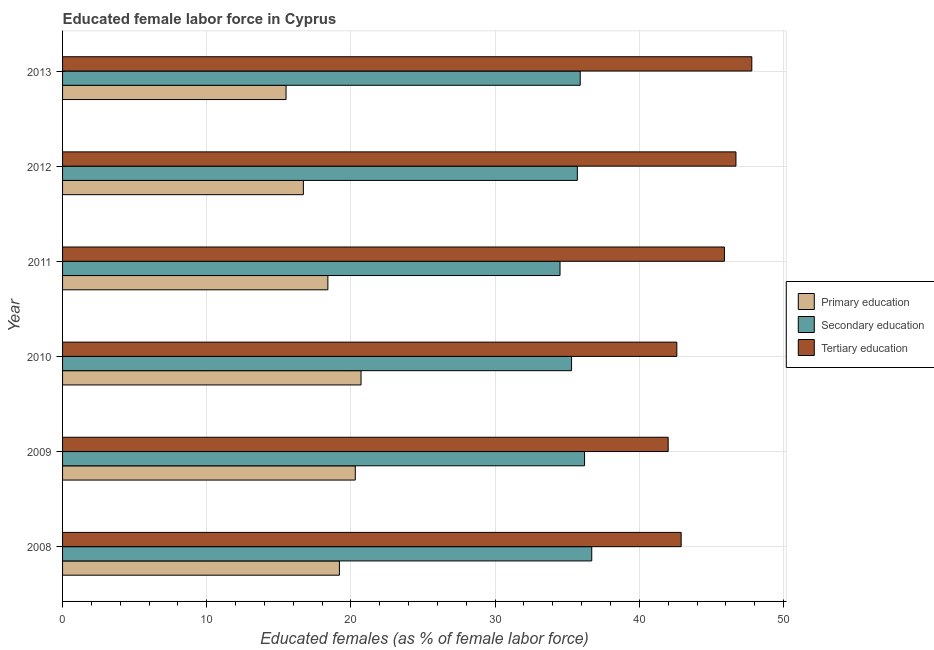How many different coloured bars are there?
Your response must be concise. 3. Are the number of bars on each tick of the Y-axis equal?
Your response must be concise. Yes. What is the percentage of female labor force who received tertiary education in 2008?
Provide a succinct answer. 42.9. Across all years, what is the maximum percentage of female labor force who received primary education?
Offer a very short reply. 20.7. Across all years, what is the minimum percentage of female labor force who received primary education?
Provide a short and direct response. 15.5. In which year was the percentage of female labor force who received primary education maximum?
Make the answer very short. 2010. In which year was the percentage of female labor force who received primary education minimum?
Offer a terse response. 2013. What is the total percentage of female labor force who received tertiary education in the graph?
Ensure brevity in your answer.  267.9. What is the difference between the percentage of female labor force who received tertiary education in 2009 and that in 2011?
Give a very brief answer. -3.9. What is the average percentage of female labor force who received secondary education per year?
Offer a very short reply. 35.72. What is the ratio of the percentage of female labor force who received tertiary education in 2008 to that in 2013?
Keep it short and to the point. 0.9. Is the percentage of female labor force who received primary education in 2010 less than that in 2012?
Ensure brevity in your answer.  No. Is the difference between the percentage of female labor force who received tertiary education in 2010 and 2011 greater than the difference between the percentage of female labor force who received primary education in 2010 and 2011?
Offer a terse response. No. What does the 1st bar from the top in 2008 represents?
Offer a very short reply. Tertiary education. What does the 2nd bar from the bottom in 2011 represents?
Make the answer very short. Secondary education. Is it the case that in every year, the sum of the percentage of female labor force who received primary education and percentage of female labor force who received secondary education is greater than the percentage of female labor force who received tertiary education?
Ensure brevity in your answer.  Yes. Are all the bars in the graph horizontal?
Your response must be concise. Yes. Are the values on the major ticks of X-axis written in scientific E-notation?
Provide a short and direct response. No. Does the graph contain any zero values?
Make the answer very short. No. Where does the legend appear in the graph?
Make the answer very short. Center right. How many legend labels are there?
Ensure brevity in your answer.  3. What is the title of the graph?
Give a very brief answer. Educated female labor force in Cyprus. Does "Manufactures" appear as one of the legend labels in the graph?
Give a very brief answer. No. What is the label or title of the X-axis?
Your answer should be very brief. Educated females (as % of female labor force). What is the Educated females (as % of female labor force) of Primary education in 2008?
Ensure brevity in your answer.  19.2. What is the Educated females (as % of female labor force) of Secondary education in 2008?
Make the answer very short. 36.7. What is the Educated females (as % of female labor force) of Tertiary education in 2008?
Offer a terse response. 42.9. What is the Educated females (as % of female labor force) in Primary education in 2009?
Provide a short and direct response. 20.3. What is the Educated females (as % of female labor force) of Secondary education in 2009?
Your answer should be compact. 36.2. What is the Educated females (as % of female labor force) of Tertiary education in 2009?
Your answer should be very brief. 42. What is the Educated females (as % of female labor force) of Primary education in 2010?
Give a very brief answer. 20.7. What is the Educated females (as % of female labor force) of Secondary education in 2010?
Your response must be concise. 35.3. What is the Educated females (as % of female labor force) in Tertiary education in 2010?
Give a very brief answer. 42.6. What is the Educated females (as % of female labor force) of Primary education in 2011?
Your response must be concise. 18.4. What is the Educated females (as % of female labor force) in Secondary education in 2011?
Ensure brevity in your answer.  34.5. What is the Educated females (as % of female labor force) of Tertiary education in 2011?
Your answer should be compact. 45.9. What is the Educated females (as % of female labor force) in Primary education in 2012?
Provide a succinct answer. 16.7. What is the Educated females (as % of female labor force) in Secondary education in 2012?
Provide a short and direct response. 35.7. What is the Educated females (as % of female labor force) of Tertiary education in 2012?
Ensure brevity in your answer.  46.7. What is the Educated females (as % of female labor force) of Secondary education in 2013?
Your answer should be very brief. 35.9. What is the Educated females (as % of female labor force) in Tertiary education in 2013?
Provide a succinct answer. 47.8. Across all years, what is the maximum Educated females (as % of female labor force) in Primary education?
Ensure brevity in your answer.  20.7. Across all years, what is the maximum Educated females (as % of female labor force) of Secondary education?
Provide a short and direct response. 36.7. Across all years, what is the maximum Educated females (as % of female labor force) in Tertiary education?
Give a very brief answer. 47.8. Across all years, what is the minimum Educated females (as % of female labor force) in Primary education?
Keep it short and to the point. 15.5. Across all years, what is the minimum Educated females (as % of female labor force) of Secondary education?
Keep it short and to the point. 34.5. What is the total Educated females (as % of female labor force) of Primary education in the graph?
Your response must be concise. 110.8. What is the total Educated females (as % of female labor force) of Secondary education in the graph?
Your response must be concise. 214.3. What is the total Educated females (as % of female labor force) in Tertiary education in the graph?
Keep it short and to the point. 267.9. What is the difference between the Educated females (as % of female labor force) of Primary education in 2008 and that in 2009?
Provide a succinct answer. -1.1. What is the difference between the Educated females (as % of female labor force) in Tertiary education in 2008 and that in 2009?
Give a very brief answer. 0.9. What is the difference between the Educated females (as % of female labor force) in Primary education in 2008 and that in 2010?
Provide a short and direct response. -1.5. What is the difference between the Educated females (as % of female labor force) in Secondary education in 2008 and that in 2010?
Your answer should be compact. 1.4. What is the difference between the Educated females (as % of female labor force) of Tertiary education in 2008 and that in 2010?
Your answer should be very brief. 0.3. What is the difference between the Educated females (as % of female labor force) in Primary education in 2008 and that in 2011?
Offer a very short reply. 0.8. What is the difference between the Educated females (as % of female labor force) in Primary education in 2008 and that in 2013?
Offer a terse response. 3.7. What is the difference between the Educated females (as % of female labor force) of Secondary education in 2008 and that in 2013?
Give a very brief answer. 0.8. What is the difference between the Educated females (as % of female labor force) in Tertiary education in 2008 and that in 2013?
Make the answer very short. -4.9. What is the difference between the Educated females (as % of female labor force) in Secondary education in 2009 and that in 2010?
Offer a terse response. 0.9. What is the difference between the Educated females (as % of female labor force) in Primary education in 2009 and that in 2012?
Keep it short and to the point. 3.6. What is the difference between the Educated females (as % of female labor force) of Tertiary education in 2009 and that in 2012?
Make the answer very short. -4.7. What is the difference between the Educated females (as % of female labor force) in Primary education in 2009 and that in 2013?
Offer a terse response. 4.8. What is the difference between the Educated females (as % of female labor force) in Secondary education in 2010 and that in 2011?
Offer a very short reply. 0.8. What is the difference between the Educated females (as % of female labor force) of Secondary education in 2010 and that in 2012?
Give a very brief answer. -0.4. What is the difference between the Educated females (as % of female labor force) of Tertiary education in 2010 and that in 2012?
Your response must be concise. -4.1. What is the difference between the Educated females (as % of female labor force) of Primary education in 2010 and that in 2013?
Keep it short and to the point. 5.2. What is the difference between the Educated females (as % of female labor force) of Secondary education in 2010 and that in 2013?
Offer a terse response. -0.6. What is the difference between the Educated females (as % of female labor force) in Secondary education in 2011 and that in 2012?
Keep it short and to the point. -1.2. What is the difference between the Educated females (as % of female labor force) in Primary education in 2012 and that in 2013?
Keep it short and to the point. 1.2. What is the difference between the Educated females (as % of female labor force) of Secondary education in 2012 and that in 2013?
Your answer should be very brief. -0.2. What is the difference between the Educated females (as % of female labor force) in Primary education in 2008 and the Educated females (as % of female labor force) in Secondary education in 2009?
Provide a succinct answer. -17. What is the difference between the Educated females (as % of female labor force) in Primary education in 2008 and the Educated females (as % of female labor force) in Tertiary education in 2009?
Provide a succinct answer. -22.8. What is the difference between the Educated females (as % of female labor force) of Secondary education in 2008 and the Educated females (as % of female labor force) of Tertiary education in 2009?
Your answer should be compact. -5.3. What is the difference between the Educated females (as % of female labor force) of Primary education in 2008 and the Educated females (as % of female labor force) of Secondary education in 2010?
Keep it short and to the point. -16.1. What is the difference between the Educated females (as % of female labor force) of Primary education in 2008 and the Educated females (as % of female labor force) of Tertiary education in 2010?
Make the answer very short. -23.4. What is the difference between the Educated females (as % of female labor force) in Secondary education in 2008 and the Educated females (as % of female labor force) in Tertiary education in 2010?
Your response must be concise. -5.9. What is the difference between the Educated females (as % of female labor force) in Primary education in 2008 and the Educated females (as % of female labor force) in Secondary education in 2011?
Give a very brief answer. -15.3. What is the difference between the Educated females (as % of female labor force) in Primary education in 2008 and the Educated females (as % of female labor force) in Tertiary education in 2011?
Give a very brief answer. -26.7. What is the difference between the Educated females (as % of female labor force) of Secondary education in 2008 and the Educated females (as % of female labor force) of Tertiary education in 2011?
Give a very brief answer. -9.2. What is the difference between the Educated females (as % of female labor force) of Primary education in 2008 and the Educated females (as % of female labor force) of Secondary education in 2012?
Give a very brief answer. -16.5. What is the difference between the Educated females (as % of female labor force) in Primary education in 2008 and the Educated females (as % of female labor force) in Tertiary education in 2012?
Provide a succinct answer. -27.5. What is the difference between the Educated females (as % of female labor force) of Primary education in 2008 and the Educated females (as % of female labor force) of Secondary education in 2013?
Your answer should be compact. -16.7. What is the difference between the Educated females (as % of female labor force) of Primary education in 2008 and the Educated females (as % of female labor force) of Tertiary education in 2013?
Your answer should be very brief. -28.6. What is the difference between the Educated females (as % of female labor force) in Primary education in 2009 and the Educated females (as % of female labor force) in Secondary education in 2010?
Offer a terse response. -15. What is the difference between the Educated females (as % of female labor force) of Primary education in 2009 and the Educated females (as % of female labor force) of Tertiary education in 2010?
Ensure brevity in your answer.  -22.3. What is the difference between the Educated females (as % of female labor force) of Primary education in 2009 and the Educated females (as % of female labor force) of Secondary education in 2011?
Make the answer very short. -14.2. What is the difference between the Educated females (as % of female labor force) of Primary education in 2009 and the Educated females (as % of female labor force) of Tertiary education in 2011?
Your response must be concise. -25.6. What is the difference between the Educated females (as % of female labor force) of Primary education in 2009 and the Educated females (as % of female labor force) of Secondary education in 2012?
Your answer should be compact. -15.4. What is the difference between the Educated females (as % of female labor force) of Primary education in 2009 and the Educated females (as % of female labor force) of Tertiary education in 2012?
Provide a short and direct response. -26.4. What is the difference between the Educated females (as % of female labor force) of Primary education in 2009 and the Educated females (as % of female labor force) of Secondary education in 2013?
Your answer should be very brief. -15.6. What is the difference between the Educated females (as % of female labor force) in Primary education in 2009 and the Educated females (as % of female labor force) in Tertiary education in 2013?
Ensure brevity in your answer.  -27.5. What is the difference between the Educated females (as % of female labor force) of Primary education in 2010 and the Educated females (as % of female labor force) of Tertiary education in 2011?
Ensure brevity in your answer.  -25.2. What is the difference between the Educated females (as % of female labor force) in Primary education in 2010 and the Educated females (as % of female labor force) in Secondary education in 2012?
Your answer should be compact. -15. What is the difference between the Educated females (as % of female labor force) of Primary education in 2010 and the Educated females (as % of female labor force) of Secondary education in 2013?
Offer a very short reply. -15.2. What is the difference between the Educated females (as % of female labor force) of Primary education in 2010 and the Educated females (as % of female labor force) of Tertiary education in 2013?
Ensure brevity in your answer.  -27.1. What is the difference between the Educated females (as % of female labor force) of Secondary education in 2010 and the Educated females (as % of female labor force) of Tertiary education in 2013?
Ensure brevity in your answer.  -12.5. What is the difference between the Educated females (as % of female labor force) of Primary education in 2011 and the Educated females (as % of female labor force) of Secondary education in 2012?
Ensure brevity in your answer.  -17.3. What is the difference between the Educated females (as % of female labor force) in Primary education in 2011 and the Educated females (as % of female labor force) in Tertiary education in 2012?
Your answer should be very brief. -28.3. What is the difference between the Educated females (as % of female labor force) of Primary education in 2011 and the Educated females (as % of female labor force) of Secondary education in 2013?
Your response must be concise. -17.5. What is the difference between the Educated females (as % of female labor force) in Primary education in 2011 and the Educated females (as % of female labor force) in Tertiary education in 2013?
Provide a short and direct response. -29.4. What is the difference between the Educated females (as % of female labor force) in Primary education in 2012 and the Educated females (as % of female labor force) in Secondary education in 2013?
Offer a terse response. -19.2. What is the difference between the Educated females (as % of female labor force) of Primary education in 2012 and the Educated females (as % of female labor force) of Tertiary education in 2013?
Your response must be concise. -31.1. What is the difference between the Educated females (as % of female labor force) in Secondary education in 2012 and the Educated females (as % of female labor force) in Tertiary education in 2013?
Your answer should be compact. -12.1. What is the average Educated females (as % of female labor force) of Primary education per year?
Offer a very short reply. 18.47. What is the average Educated females (as % of female labor force) of Secondary education per year?
Offer a terse response. 35.72. What is the average Educated females (as % of female labor force) in Tertiary education per year?
Your response must be concise. 44.65. In the year 2008, what is the difference between the Educated females (as % of female labor force) of Primary education and Educated females (as % of female labor force) of Secondary education?
Give a very brief answer. -17.5. In the year 2008, what is the difference between the Educated females (as % of female labor force) of Primary education and Educated females (as % of female labor force) of Tertiary education?
Provide a short and direct response. -23.7. In the year 2009, what is the difference between the Educated females (as % of female labor force) of Primary education and Educated females (as % of female labor force) of Secondary education?
Ensure brevity in your answer.  -15.9. In the year 2009, what is the difference between the Educated females (as % of female labor force) in Primary education and Educated females (as % of female labor force) in Tertiary education?
Make the answer very short. -21.7. In the year 2010, what is the difference between the Educated females (as % of female labor force) of Primary education and Educated females (as % of female labor force) of Secondary education?
Make the answer very short. -14.6. In the year 2010, what is the difference between the Educated females (as % of female labor force) of Primary education and Educated females (as % of female labor force) of Tertiary education?
Provide a succinct answer. -21.9. In the year 2010, what is the difference between the Educated females (as % of female labor force) of Secondary education and Educated females (as % of female labor force) of Tertiary education?
Give a very brief answer. -7.3. In the year 2011, what is the difference between the Educated females (as % of female labor force) in Primary education and Educated females (as % of female labor force) in Secondary education?
Offer a terse response. -16.1. In the year 2011, what is the difference between the Educated females (as % of female labor force) of Primary education and Educated females (as % of female labor force) of Tertiary education?
Ensure brevity in your answer.  -27.5. In the year 2012, what is the difference between the Educated females (as % of female labor force) in Secondary education and Educated females (as % of female labor force) in Tertiary education?
Offer a very short reply. -11. In the year 2013, what is the difference between the Educated females (as % of female labor force) of Primary education and Educated females (as % of female labor force) of Secondary education?
Offer a terse response. -20.4. In the year 2013, what is the difference between the Educated females (as % of female labor force) of Primary education and Educated females (as % of female labor force) of Tertiary education?
Give a very brief answer. -32.3. In the year 2013, what is the difference between the Educated females (as % of female labor force) in Secondary education and Educated females (as % of female labor force) in Tertiary education?
Offer a terse response. -11.9. What is the ratio of the Educated females (as % of female labor force) of Primary education in 2008 to that in 2009?
Provide a short and direct response. 0.95. What is the ratio of the Educated females (as % of female labor force) of Secondary education in 2008 to that in 2009?
Keep it short and to the point. 1.01. What is the ratio of the Educated females (as % of female labor force) of Tertiary education in 2008 to that in 2009?
Your answer should be very brief. 1.02. What is the ratio of the Educated females (as % of female labor force) of Primary education in 2008 to that in 2010?
Provide a succinct answer. 0.93. What is the ratio of the Educated females (as % of female labor force) of Secondary education in 2008 to that in 2010?
Provide a succinct answer. 1.04. What is the ratio of the Educated females (as % of female labor force) in Primary education in 2008 to that in 2011?
Make the answer very short. 1.04. What is the ratio of the Educated females (as % of female labor force) in Secondary education in 2008 to that in 2011?
Give a very brief answer. 1.06. What is the ratio of the Educated females (as % of female labor force) in Tertiary education in 2008 to that in 2011?
Your response must be concise. 0.93. What is the ratio of the Educated females (as % of female labor force) in Primary education in 2008 to that in 2012?
Your answer should be compact. 1.15. What is the ratio of the Educated females (as % of female labor force) in Secondary education in 2008 to that in 2012?
Offer a very short reply. 1.03. What is the ratio of the Educated females (as % of female labor force) in Tertiary education in 2008 to that in 2012?
Your answer should be compact. 0.92. What is the ratio of the Educated females (as % of female labor force) of Primary education in 2008 to that in 2013?
Offer a very short reply. 1.24. What is the ratio of the Educated females (as % of female labor force) in Secondary education in 2008 to that in 2013?
Ensure brevity in your answer.  1.02. What is the ratio of the Educated females (as % of female labor force) of Tertiary education in 2008 to that in 2013?
Your answer should be compact. 0.9. What is the ratio of the Educated females (as % of female labor force) in Primary education in 2009 to that in 2010?
Give a very brief answer. 0.98. What is the ratio of the Educated females (as % of female labor force) of Secondary education in 2009 to that in 2010?
Your answer should be compact. 1.03. What is the ratio of the Educated females (as % of female labor force) of Tertiary education in 2009 to that in 2010?
Ensure brevity in your answer.  0.99. What is the ratio of the Educated females (as % of female labor force) in Primary education in 2009 to that in 2011?
Provide a succinct answer. 1.1. What is the ratio of the Educated females (as % of female labor force) of Secondary education in 2009 to that in 2011?
Give a very brief answer. 1.05. What is the ratio of the Educated females (as % of female labor force) of Tertiary education in 2009 to that in 2011?
Ensure brevity in your answer.  0.92. What is the ratio of the Educated females (as % of female labor force) of Primary education in 2009 to that in 2012?
Your response must be concise. 1.22. What is the ratio of the Educated females (as % of female labor force) of Secondary education in 2009 to that in 2012?
Provide a short and direct response. 1.01. What is the ratio of the Educated females (as % of female labor force) in Tertiary education in 2009 to that in 2012?
Keep it short and to the point. 0.9. What is the ratio of the Educated females (as % of female labor force) in Primary education in 2009 to that in 2013?
Your response must be concise. 1.31. What is the ratio of the Educated females (as % of female labor force) of Secondary education in 2009 to that in 2013?
Provide a short and direct response. 1.01. What is the ratio of the Educated females (as % of female labor force) in Tertiary education in 2009 to that in 2013?
Your answer should be very brief. 0.88. What is the ratio of the Educated females (as % of female labor force) in Secondary education in 2010 to that in 2011?
Offer a terse response. 1.02. What is the ratio of the Educated females (as % of female labor force) of Tertiary education in 2010 to that in 2011?
Provide a succinct answer. 0.93. What is the ratio of the Educated females (as % of female labor force) in Primary education in 2010 to that in 2012?
Make the answer very short. 1.24. What is the ratio of the Educated females (as % of female labor force) in Secondary education in 2010 to that in 2012?
Your response must be concise. 0.99. What is the ratio of the Educated females (as % of female labor force) of Tertiary education in 2010 to that in 2012?
Your answer should be very brief. 0.91. What is the ratio of the Educated females (as % of female labor force) in Primary education in 2010 to that in 2013?
Make the answer very short. 1.34. What is the ratio of the Educated females (as % of female labor force) of Secondary education in 2010 to that in 2013?
Keep it short and to the point. 0.98. What is the ratio of the Educated females (as % of female labor force) of Tertiary education in 2010 to that in 2013?
Offer a very short reply. 0.89. What is the ratio of the Educated females (as % of female labor force) of Primary education in 2011 to that in 2012?
Your response must be concise. 1.1. What is the ratio of the Educated females (as % of female labor force) of Secondary education in 2011 to that in 2012?
Offer a very short reply. 0.97. What is the ratio of the Educated females (as % of female labor force) in Tertiary education in 2011 to that in 2012?
Provide a short and direct response. 0.98. What is the ratio of the Educated females (as % of female labor force) of Primary education in 2011 to that in 2013?
Your answer should be compact. 1.19. What is the ratio of the Educated females (as % of female labor force) in Secondary education in 2011 to that in 2013?
Provide a succinct answer. 0.96. What is the ratio of the Educated females (as % of female labor force) in Tertiary education in 2011 to that in 2013?
Offer a terse response. 0.96. What is the ratio of the Educated females (as % of female labor force) in Primary education in 2012 to that in 2013?
Give a very brief answer. 1.08. What is the difference between the highest and the second highest Educated females (as % of female labor force) of Tertiary education?
Ensure brevity in your answer.  1.1. What is the difference between the highest and the lowest Educated females (as % of female labor force) in Primary education?
Provide a short and direct response. 5.2. What is the difference between the highest and the lowest Educated females (as % of female labor force) of Secondary education?
Your response must be concise. 2.2. 